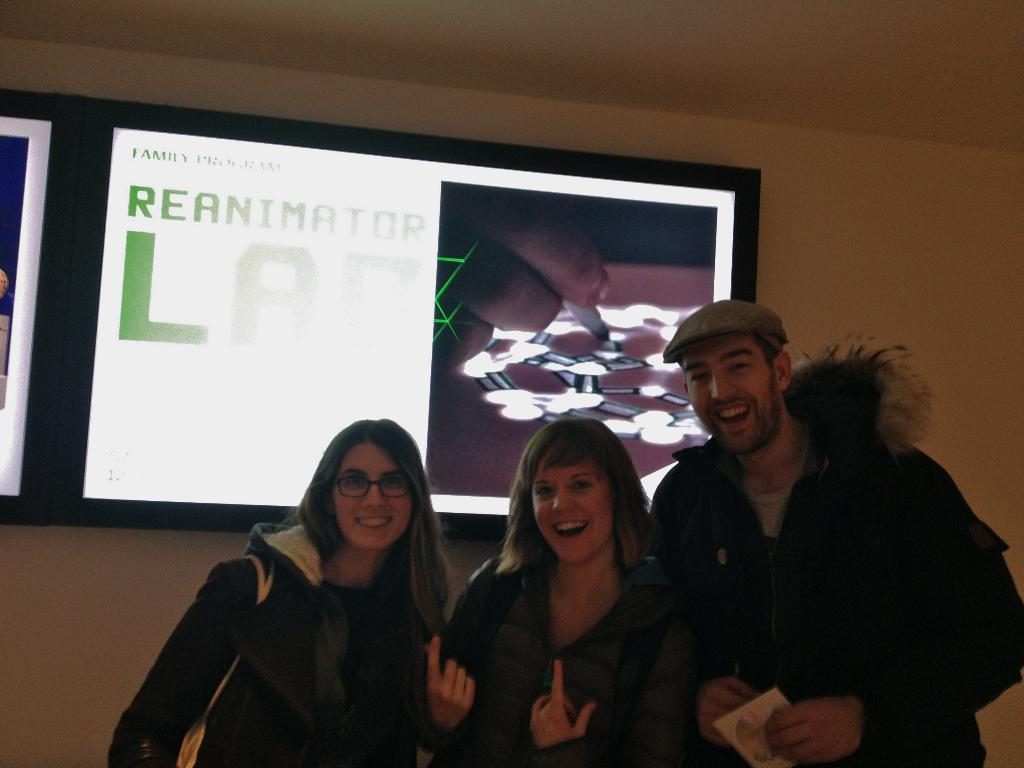What can be seen in the image involving people? There are people standing in the image. What is present on the wall in the image? There is a digital display board on the wall. Can you describe the wall in the image? The wall has a digital display board on it. What type of grass can be seen growing near the people in the image? There is no grass visible in the image; it features people standing near a wall with a digital display board. What type of voyage is being depicted on the digital display board in the image? The digital display board in the image does not depict any voyage; it is not mentioned in the provided facts. 